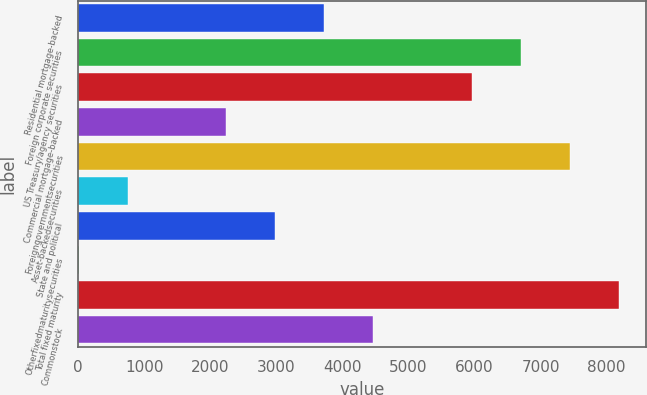<chart> <loc_0><loc_0><loc_500><loc_500><bar_chart><fcel>Residential mortgage-backed<fcel>Foreign corporate securities<fcel>US Treasury/agency securities<fcel>Commercial mortgage-backed<fcel>Foreigngovernmentsecurities<fcel>Asset-backedsecurities<fcel>State and political<fcel>Otherfixedmaturitysecurities<fcel>Total fixed maturity<fcel>Commonstock<nl><fcel>3725<fcel>6699.4<fcel>5955.8<fcel>2237.8<fcel>7443<fcel>750.6<fcel>2981.4<fcel>7<fcel>8186.6<fcel>4468.6<nl></chart> 